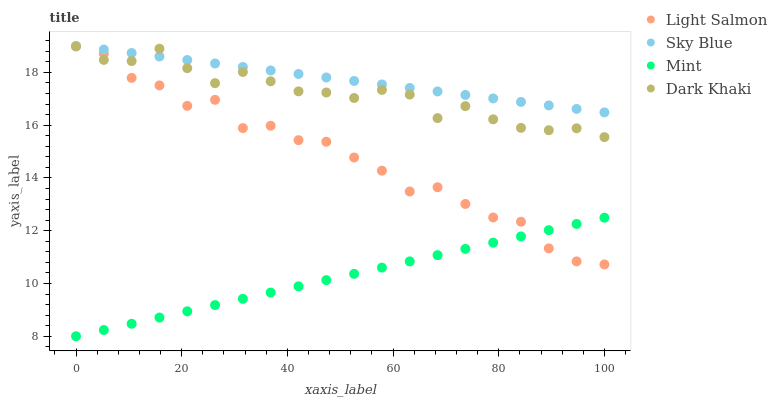Does Mint have the minimum area under the curve?
Answer yes or no. Yes. Does Sky Blue have the maximum area under the curve?
Answer yes or no. Yes. Does Light Salmon have the minimum area under the curve?
Answer yes or no. No. Does Light Salmon have the maximum area under the curve?
Answer yes or no. No. Is Mint the smoothest?
Answer yes or no. Yes. Is Light Salmon the roughest?
Answer yes or no. Yes. Is Sky Blue the smoothest?
Answer yes or no. No. Is Sky Blue the roughest?
Answer yes or no. No. Does Mint have the lowest value?
Answer yes or no. Yes. Does Light Salmon have the lowest value?
Answer yes or no. No. Does Light Salmon have the highest value?
Answer yes or no. Yes. Does Mint have the highest value?
Answer yes or no. No. Is Mint less than Dark Khaki?
Answer yes or no. Yes. Is Dark Khaki greater than Mint?
Answer yes or no. Yes. Does Dark Khaki intersect Sky Blue?
Answer yes or no. Yes. Is Dark Khaki less than Sky Blue?
Answer yes or no. No. Is Dark Khaki greater than Sky Blue?
Answer yes or no. No. Does Mint intersect Dark Khaki?
Answer yes or no. No. 